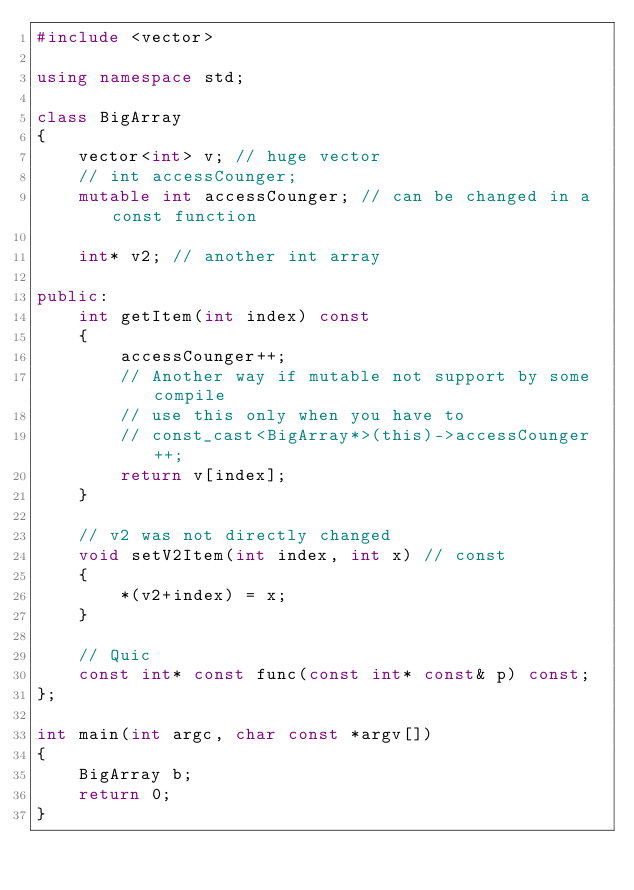<code> <loc_0><loc_0><loc_500><loc_500><_C++_>#include <vector>

using namespace std;

class BigArray
{
    vector<int> v; // huge vector
    // int accessCounger;
    mutable int accessCounger; // can be changed in a const function

    int* v2; // another int array

public:
    int getItem(int index) const
    {
        accessCounger++;
        // Another way if mutable not support by some compile
        // use this only when you have to
        // const_cast<BigArray*>(this)->accessCounger++;
        return v[index];
    }

    // v2 was not directly changed
    void setV2Item(int index, int x) // const
    {
        *(v2+index) = x;
    }

    // Quic
    const int* const func(const int* const& p) const;
};

int main(int argc, char const *argv[])
{
    BigArray b;
    return 0;
}
</code> 